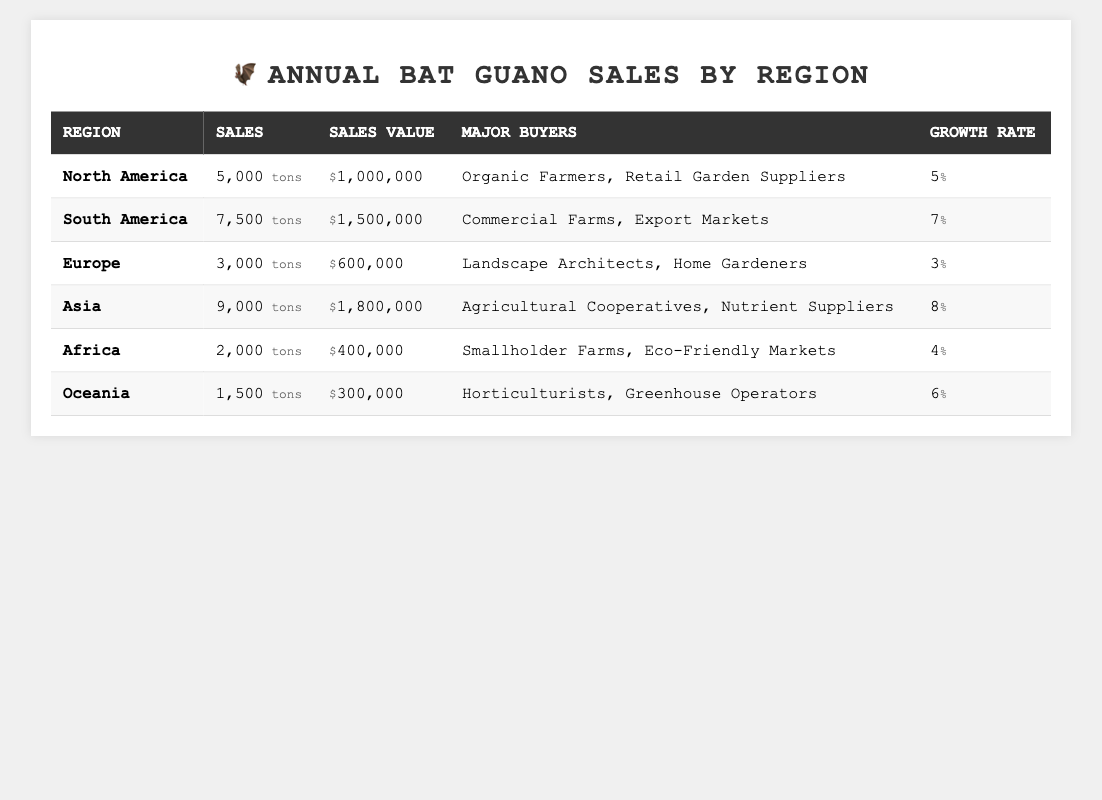What is the total sales in tons for North America and Europe combined? The sales for North America is 5,000 tons and for Europe is 3,000 tons. Adding them together gives 5,000 + 3,000 = 8,000 tons.
Answer: 8,000 tons Which region has the highest sales value? The regions and their sales values are: North America - $1,000,000, South America - $1,500,000, Europe - $600,000, Asia - $1,800,000, Africa - $400,000, Oceania - $300,000. The highest is Asia with $1,800,000.
Answer: Asia Is the growth rate in Oceania higher than in Africa? Oceania has a growth rate of 6%, while Africa has 4%. Since 6% is greater than 4%, the statement is true.
Answer: Yes What is the average sales value across all regions? Calculate the total sales value: $1,000,000 (NA) + $1,500,000 (SA) + $600,000 (EU) + $1,800,000 (AS) + $400,000 (AF) + $300,000 (OC) = $5,600,000. There are 6 regions, so the average sales value is $5,600,000 / 6 = $933,333.33.
Answer: $933,333.33 Which region has the lowest sales in tons, and what is the amount? Looking at the table, Oceania has the lowest sales with 1,500 tons.
Answer: Oceania, 1,500 tons Are there any regions where the major buyers include 'Eco-Friendly Markets'? The table lists Africa as having major buyers that include 'Eco-Friendly Markets'. So the answer is yes.
Answer: Yes What is the sales value difference between Asia and South America? Asia's sales value is $1,800,000 and South America's is $1,500,000. The difference is $1,800,000 - $1,500,000 = $300,000.
Answer: $300,000 If we rank the regions according to their growth rates, which region ranks second? The growth rates are: Asia (8%), South America (7%), North America (5%), Oceania (6%), Africa (4%), and Europe (3%). Ranking them, the second is South America with a growth rate of 7%.
Answer: South America How many tons of bat guano did Africa sell compared to Asia? Africa sold 2,000 tons while Asia sold 9,000 tons. To compare: 2,000 tons < 9,000 tons, so Africa sold less.
Answer: Less What percentage of total sales in tons does North America represent? Total sales in tons = 5,000 (NA) + 7,500 (SA) + 3,000 (EU) + 9,000 (AS) + 2,000 (AF) + 1,500 (OC) = 28,000 tons. North America sales = 5,000 tons; percentage = (5,000 / 28,000) * 100 = 17.86%.
Answer: 17.86% 